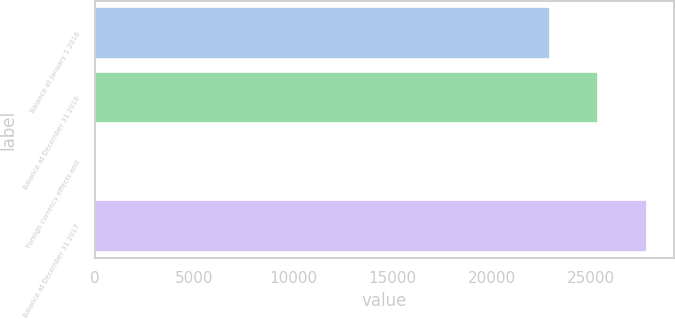Convert chart. <chart><loc_0><loc_0><loc_500><loc_500><bar_chart><fcel>Balance at January 1 2016<fcel>Balance at December 31 2016<fcel>Foreign currency effects and<fcel>Balance at December 31 2017<nl><fcel>22925<fcel>25367.4<fcel>60<fcel>27809.8<nl></chart> 